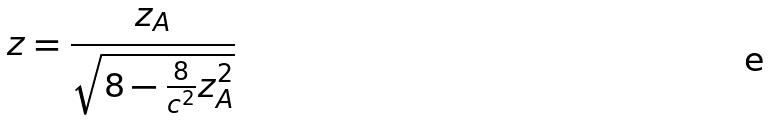Convert formula to latex. <formula><loc_0><loc_0><loc_500><loc_500>z = \frac { z _ { A } } { \sqrt { 8 - \frac { 8 } { c ^ { 2 } } z _ { A } ^ { 2 } } }</formula> 